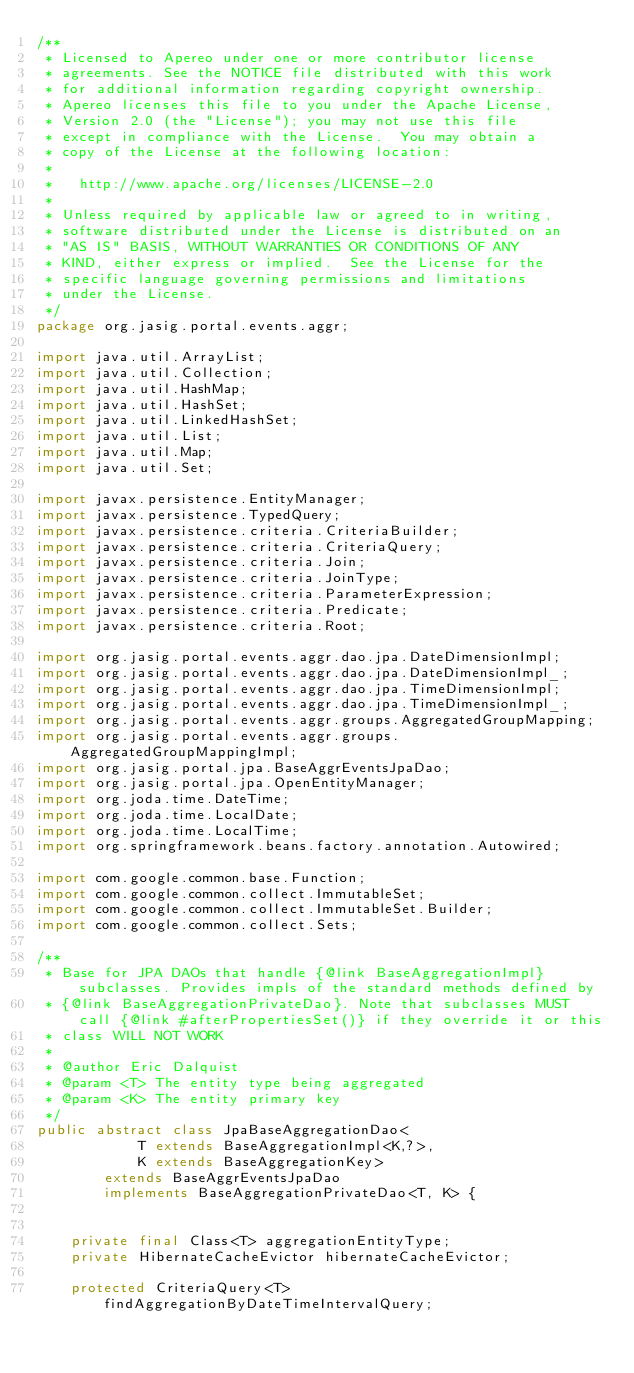<code> <loc_0><loc_0><loc_500><loc_500><_Java_>/**
 * Licensed to Apereo under one or more contributor license
 * agreements. See the NOTICE file distributed with this work
 * for additional information regarding copyright ownership.
 * Apereo licenses this file to you under the Apache License,
 * Version 2.0 (the "License"); you may not use this file
 * except in compliance with the License.  You may obtain a
 * copy of the License at the following location:
 *
 *   http://www.apache.org/licenses/LICENSE-2.0
 *
 * Unless required by applicable law or agreed to in writing,
 * software distributed under the License is distributed on an
 * "AS IS" BASIS, WITHOUT WARRANTIES OR CONDITIONS OF ANY
 * KIND, either express or implied.  See the License for the
 * specific language governing permissions and limitations
 * under the License.
 */
package org.jasig.portal.events.aggr;

import java.util.ArrayList;
import java.util.Collection;
import java.util.HashMap;
import java.util.HashSet;
import java.util.LinkedHashSet;
import java.util.List;
import java.util.Map;
import java.util.Set;

import javax.persistence.EntityManager;
import javax.persistence.TypedQuery;
import javax.persistence.criteria.CriteriaBuilder;
import javax.persistence.criteria.CriteriaQuery;
import javax.persistence.criteria.Join;
import javax.persistence.criteria.JoinType;
import javax.persistence.criteria.ParameterExpression;
import javax.persistence.criteria.Predicate;
import javax.persistence.criteria.Root;

import org.jasig.portal.events.aggr.dao.jpa.DateDimensionImpl;
import org.jasig.portal.events.aggr.dao.jpa.DateDimensionImpl_;
import org.jasig.portal.events.aggr.dao.jpa.TimeDimensionImpl;
import org.jasig.portal.events.aggr.dao.jpa.TimeDimensionImpl_;
import org.jasig.portal.events.aggr.groups.AggregatedGroupMapping;
import org.jasig.portal.events.aggr.groups.AggregatedGroupMappingImpl;
import org.jasig.portal.jpa.BaseAggrEventsJpaDao;
import org.jasig.portal.jpa.OpenEntityManager;
import org.joda.time.DateTime;
import org.joda.time.LocalDate;
import org.joda.time.LocalTime;
import org.springframework.beans.factory.annotation.Autowired;

import com.google.common.base.Function;
import com.google.common.collect.ImmutableSet;
import com.google.common.collect.ImmutableSet.Builder;
import com.google.common.collect.Sets;

/**
 * Base for JPA DAOs that handle {@link BaseAggregationImpl} subclasses. Provides impls of the standard methods defined by 
 * {@link BaseAggregationPrivateDao}. Note that subclasses MUST call {@link #afterPropertiesSet()} if they override it or this
 * class WILL NOT WORK
 * 
 * @author Eric Dalquist
 * @param <T> The entity type being aggregated
 * @param <K> The entity primary key
 */
public abstract class JpaBaseAggregationDao<
            T extends BaseAggregationImpl<K,?>,
            K extends BaseAggregationKey> 
        extends BaseAggrEventsJpaDao 
        implements BaseAggregationPrivateDao<T, K> {
    
    
    private final Class<T> aggregationEntityType;
    private HibernateCacheEvictor hibernateCacheEvictor;
    
    protected CriteriaQuery<T> findAggregationByDateTimeIntervalQuery;</code> 